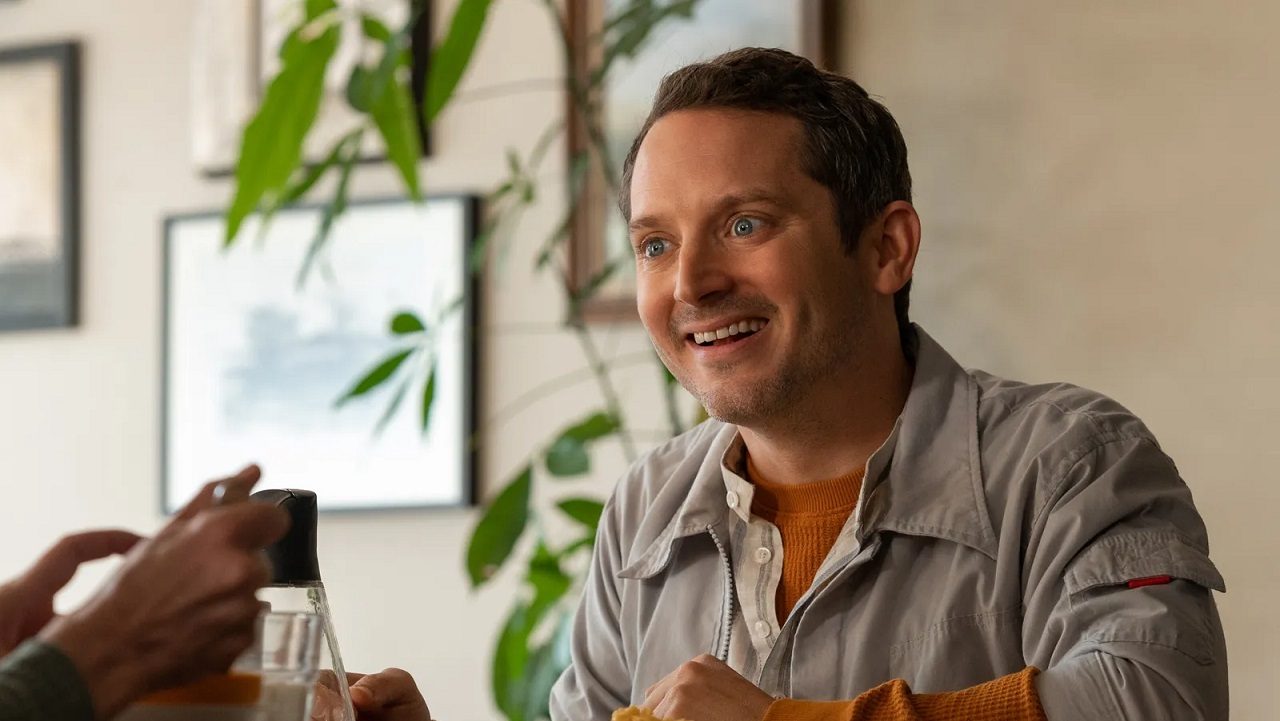Write a detailed description of the given image. The image depicts a man sitting at a table in a restaurant, radiating a cheerful demeanor. He is dressed in a light gray jacket over an orange sweater, which gives off a casual yet stylish appearance. His attention appears engaged as he smiles broadly, looking towards someone or something off-camera, suggesting a lively interaction. The setting is comfortable and adorned with green plants, which add a natural touch to an otherwise urban environment visible through the window behind him. The overall ambiance is warm and inviting, echoing a sense of contentment or a pleasant social gathering. 